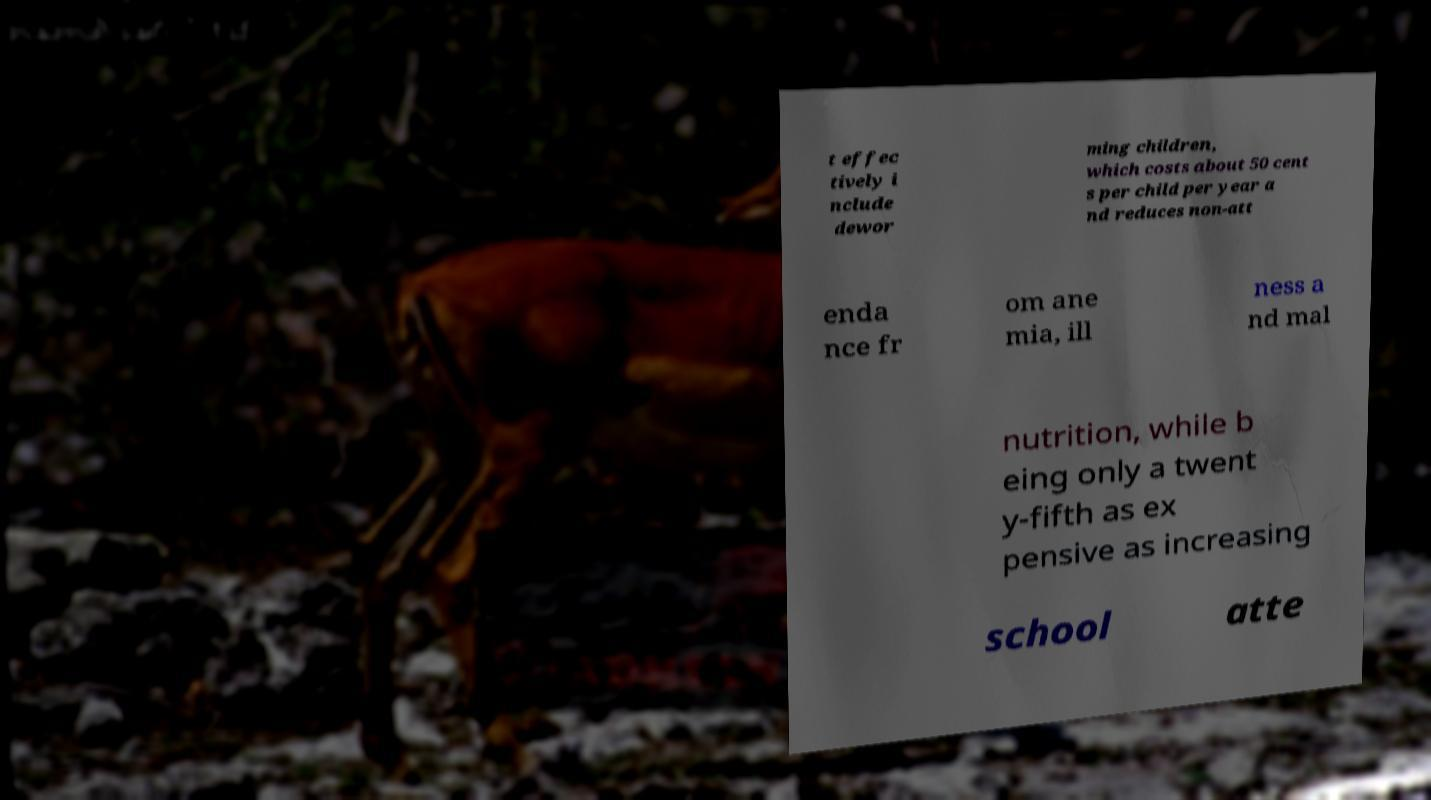Can you accurately transcribe the text from the provided image for me? t effec tively i nclude dewor ming children, which costs about 50 cent s per child per year a nd reduces non-att enda nce fr om ane mia, ill ness a nd mal nutrition, while b eing only a twent y-fifth as ex pensive as increasing school atte 